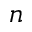<formula> <loc_0><loc_0><loc_500><loc_500>n</formula> 